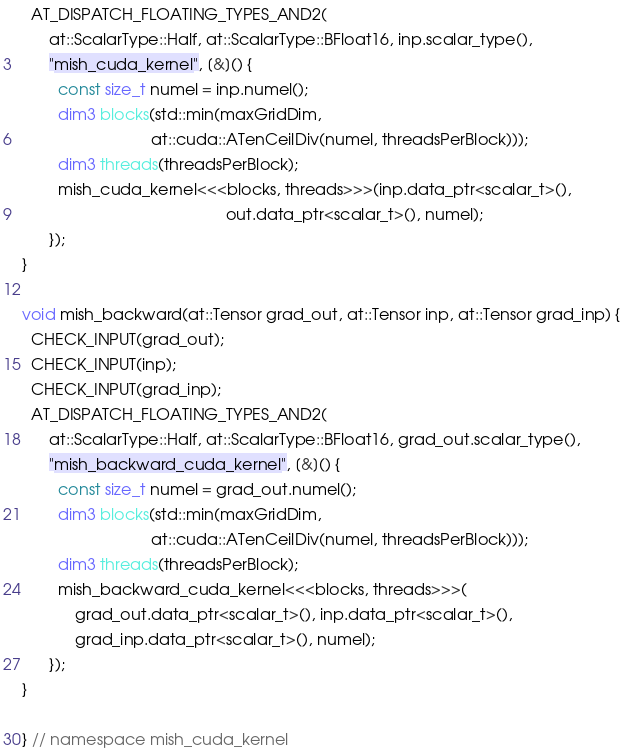Convert code to text. <code><loc_0><loc_0><loc_500><loc_500><_Cuda_>  AT_DISPATCH_FLOATING_TYPES_AND2(
      at::ScalarType::Half, at::ScalarType::BFloat16, inp.scalar_type(),
      "mish_cuda_kernel", [&]() {
        const size_t numel = inp.numel();
        dim3 blocks(std::min(maxGridDim,
                             at::cuda::ATenCeilDiv(numel, threadsPerBlock)));
        dim3 threads(threadsPerBlock);
        mish_cuda_kernel<<<blocks, threads>>>(inp.data_ptr<scalar_t>(),
                                              out.data_ptr<scalar_t>(), numel);
      });
}

void mish_backward(at::Tensor grad_out, at::Tensor inp, at::Tensor grad_inp) {
  CHECK_INPUT(grad_out);
  CHECK_INPUT(inp);
  CHECK_INPUT(grad_inp);
  AT_DISPATCH_FLOATING_TYPES_AND2(
      at::ScalarType::Half, at::ScalarType::BFloat16, grad_out.scalar_type(),
      "mish_backward_cuda_kernel", [&]() {
        const size_t numel = grad_out.numel();
        dim3 blocks(std::min(maxGridDim,
                             at::cuda::ATenCeilDiv(numel, threadsPerBlock)));
        dim3 threads(threadsPerBlock);
        mish_backward_cuda_kernel<<<blocks, threads>>>(
            grad_out.data_ptr<scalar_t>(), inp.data_ptr<scalar_t>(),
            grad_inp.data_ptr<scalar_t>(), numel);
      });
}

} // namespace mish_cuda_kernel
</code> 